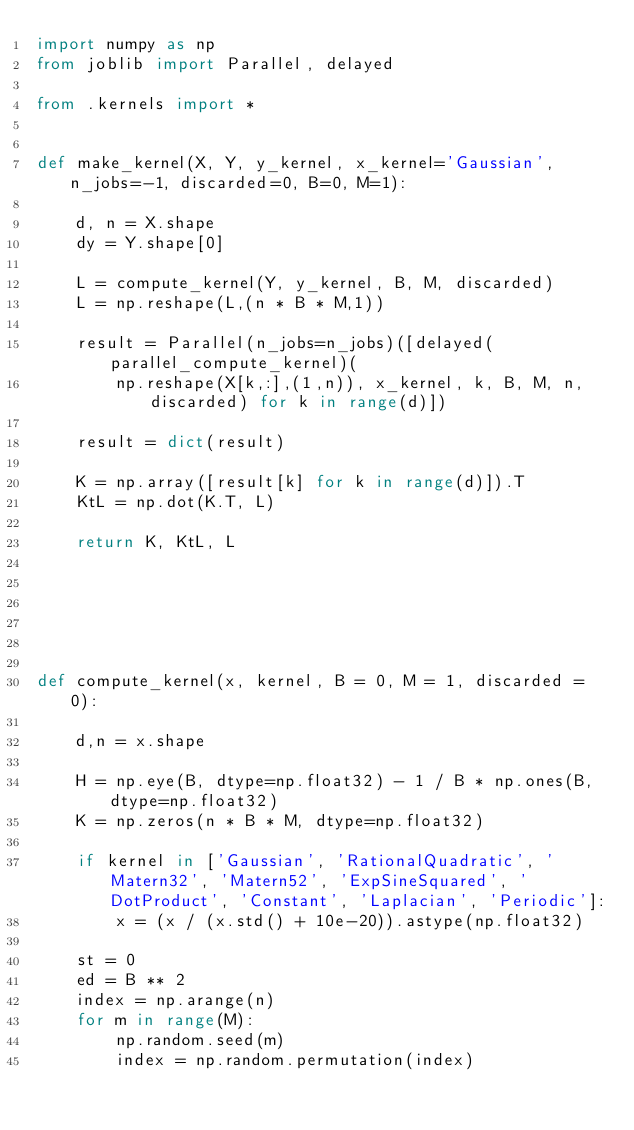<code> <loc_0><loc_0><loc_500><loc_500><_Python_>import numpy as np
from joblib import Parallel, delayed

from .kernels import *


def make_kernel(X, Y, y_kernel, x_kernel='Gaussian', n_jobs=-1, discarded=0, B=0, M=1):

    d, n = X.shape
    dy = Y.shape[0]

    L = compute_kernel(Y, y_kernel, B, M, discarded)
    L = np.reshape(L,(n * B * M,1))

    result = Parallel(n_jobs=n_jobs)([delayed(parallel_compute_kernel)(
        np.reshape(X[k,:],(1,n)), x_kernel, k, B, M, n, discarded) for k in range(d)])

    result = dict(result)

    K = np.array([result[k] for k in range(d)]).T
    KtL = np.dot(K.T, L)

    return K, KtL, L






def compute_kernel(x, kernel, B = 0, M = 1, discarded = 0):

    d,n = x.shape

    H = np.eye(B, dtype=np.float32) - 1 / B * np.ones(B, dtype=np.float32)
    K = np.zeros(n * B * M, dtype=np.float32)

    if kernel in ['Gaussian', 'RationalQuadratic', 'Matern32', 'Matern52', 'ExpSineSquared', 'DotProduct', 'Constant', 'Laplacian', 'Periodic']:
        x = (x / (x.std() + 10e-20)).astype(np.float32)

    st = 0
    ed = B ** 2
    index = np.arange(n)
    for m in range(M):
        np.random.seed(m)
        index = np.random.permutation(index)
</code> 